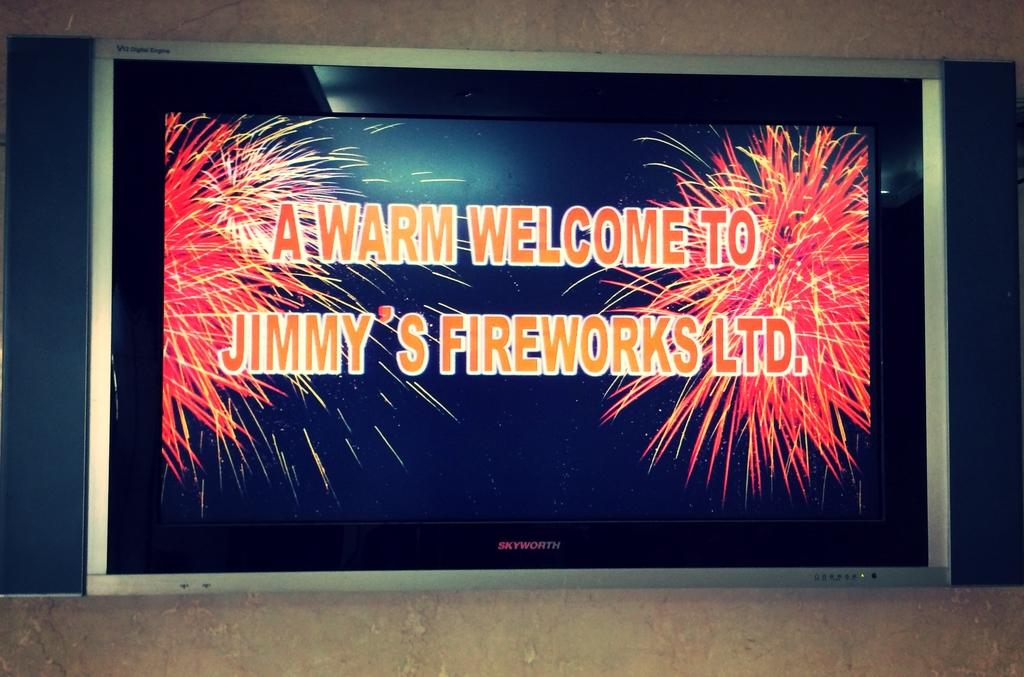<image>
Present a compact description of the photo's key features. A television screen is showing a welcoming note to Jimmy's Fireworks LTD. 